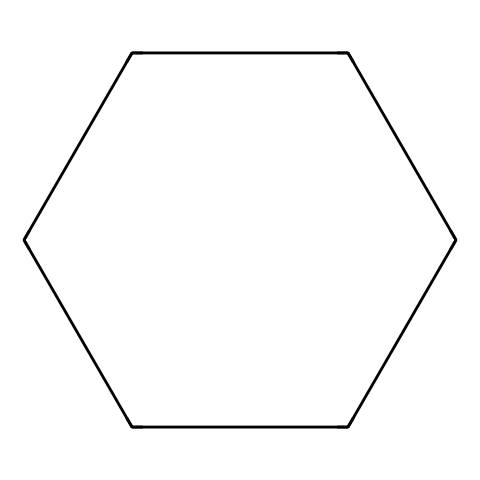What is the molecular formula of cyclohexane? The SMILES representation shows 6 carbon atoms (C) in a ring structure, and hydrogens fill each carbon's bonding capacity. The total number of hydrogen atoms is 12. Therefore, the molecular formula is C6H12.
Answer: C6H12 How many carbon atoms are present in this compound? The SMILES structure indicates that there are six 'C' symbols, each representing a carbon atom in the cyclohexane structure.
Answer: 6 What type of chemical structure does this represent? This compound is represented by a cyclic structure where the carbon atoms are connected in a ring formation, characteristic of cycloalkanes, specifically cyclohexane.
Answer: cycloalkane What is the bond angle approximation in cyclohexane? The ideal bond angles in a cyclohexane molecule, due to its tetrahedral geometry around each carbon atom, can be approximated to be around 109.5 degrees. This is due to the sp3 hybridization of carbon.
Answer: 109.5 degrees Is cyclohexane an example of a saturated hydrocarbon? There are no double or triple bonds present in the structure, and all carbon atoms are bonded to the maximum number of hydrogen atoms, affirming that cyclohexane is a saturated hydrocarbon.
Answer: Yes What type of conformations can cyclohexane adopt? Cyclohexane can adopt several conformations, primarily chair and boat forms, due to the freedom of rotation around the carbon-carbon single bonds. These conformations influence its stability and properties.
Answer: chair and boat 